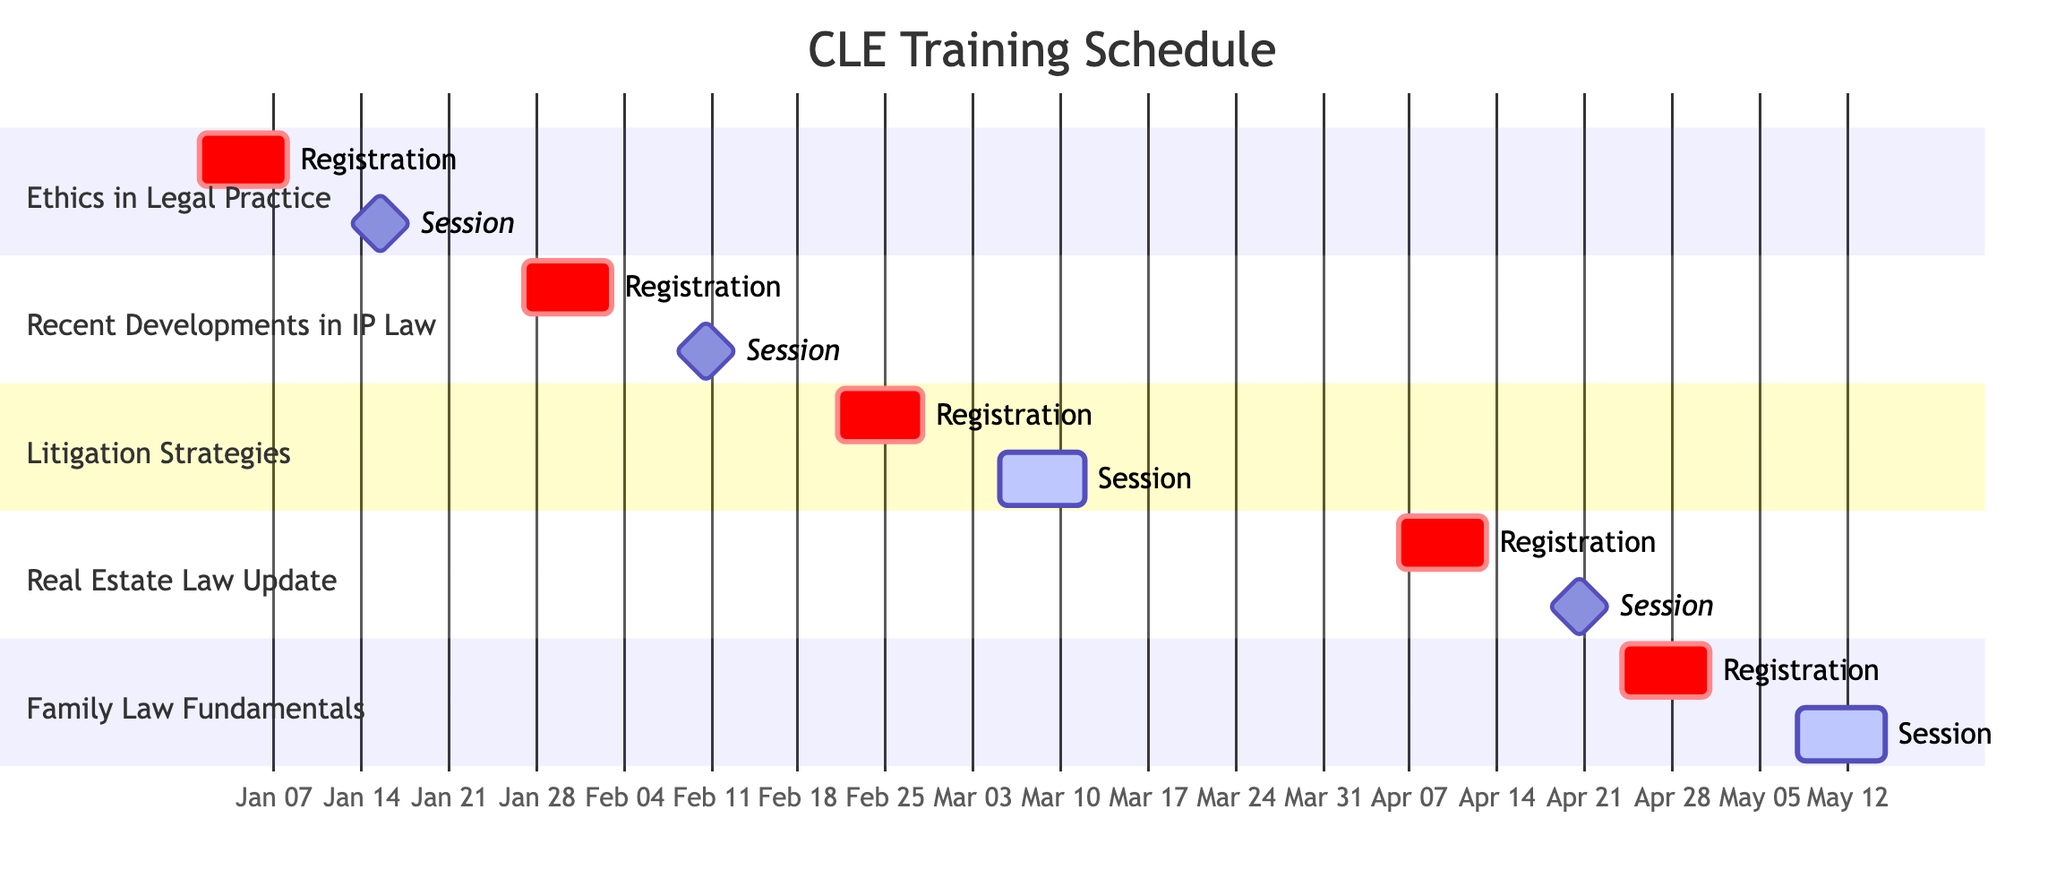What is the registration deadline for the session "Ethics in Legal Practice"? The diagram indicates the registration deadline for "Ethics in Legal Practice" starts on January 1, 2024, and ends on January 8, 2024. Thus, the answer is the end date of this registration period, which is January 8, 2024.
Answer: January 8, 2024 How long does the session on "Litigation Strategies" last? The session on "Litigation Strategies" is marked as 'active' from March 5, 2024, to March 12, 2024. To find out how long it lasts, you calculate the difference between the end date (March 12) and the start date (March 5), which gives you 7 days.
Answer: 7 days What is the topic covered in the "Family Law Fundamentals" session? In the diagram, the session "Family Law Fundamentals" is associated with the topic "Navigating Divorce and Custody Matters." This is clearly stated in the information block for that session.
Answer: Navigating Divorce and Custody Matters Which session has the earliest registration deadline? By reviewing the registration deadlines for each session listed in the diagram, the earliest registration deadline is January 8, 2024, for the session "Ethics in Legal Practice." Therefore, it is the session with the earliest deadline.
Answer: Ethics in Legal Practice For how many sessions are the registration periods active before late February 2024? Analyzing the various registration periods in the diagram, only "Ethics in Legal Practice" and "Recent Developments in Intellectual Property Law" have registration periods ending before February 28, 2024. Therefore, there are two such sessions.
Answer: 2 sessions What is the last session scheduled in the Gantt chart? The last session in the Gantt chart is "Family Law Fundamentals," which is scheduled from May 8, 2024, to May 15, 2024. This can be determined by looking at the sequence of sessions listed.
Answer: Family Law Fundamentals 